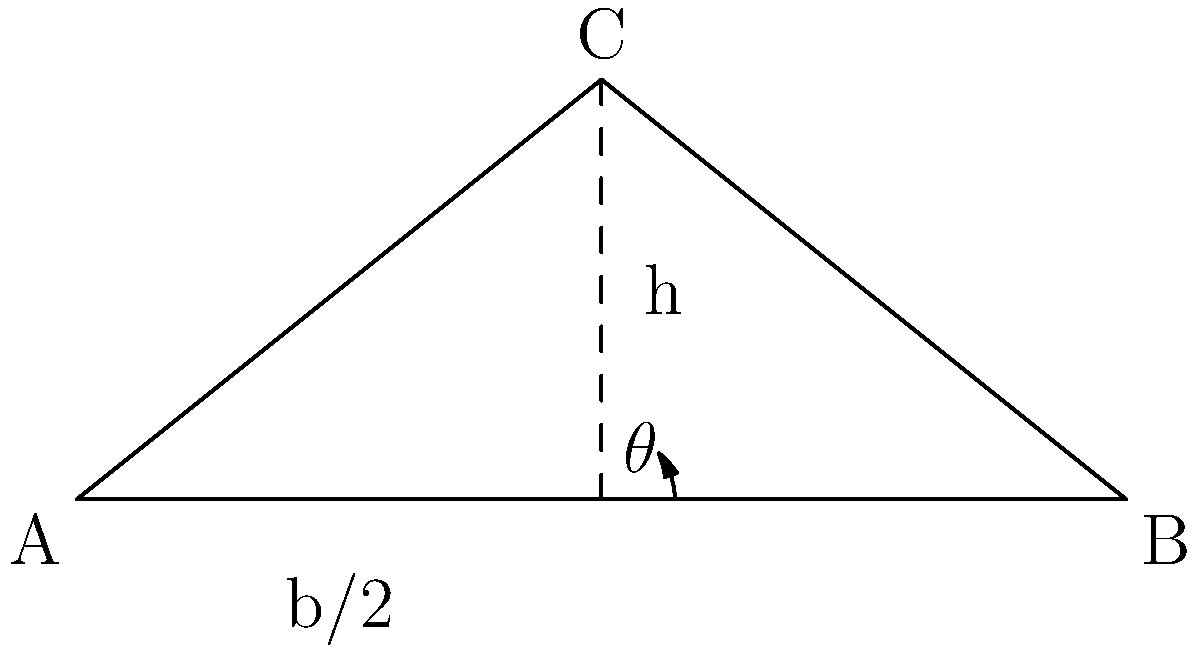As a construction project manager, you're tasked with designing a roof truss for a new house. Given that the optimal angle for a roof truss balances stability and material usage, which of the following equations would you use to determine the angle $\theta$ that maximizes the ratio of the truss height (h) to the base width (b), while minimizing material use?

a) $\tan \theta = \frac{2h}{b}$
b) $\sin \theta = \frac{2h}{b}$
c) $\cos \theta = \frac{b}{2h}$
d) $\cot \theta = \frac{b}{2h}$ To determine the optimal angle for a roof truss, we need to consider the relationship between the angle, height, and base width of the truss. Let's approach this step-by-step:

1) In the diagram, we can see a right triangle formed by half of the truss.

2) The angle $\theta$ is at the base of this right triangle.

3) The height of the triangle is h, and half of the base width is b/2.

4) In a right triangle, the tangent of an angle is defined as the ratio of the opposite side to the adjacent side.

5) In this case:
   - The side opposite to angle $\theta$ is h
   - The side adjacent to angle $\theta$ is b/2

6) Therefore, the correct relationship is:

   $\tan \theta = \frac{\text{opposite}}{\text{adjacent}} = \frac{h}{b/2} = \frac{2h}{b}$

7) This equation allows us to determine the angle $\theta$ that gives us the desired ratio of height to base width, which in turn optimizes stability and material usage.

8) Among the given options, this relationship is represented by equation a) $\tan \theta = \frac{2h}{b}$

Therefore, as a construction project manager, you would use this equation to determine the optimal angle for the roof truss.
Answer: $\tan \theta = \frac{2h}{b}$ 